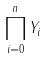<formula> <loc_0><loc_0><loc_500><loc_500>\prod _ { i = 0 } ^ { n } Y _ { i }</formula> 